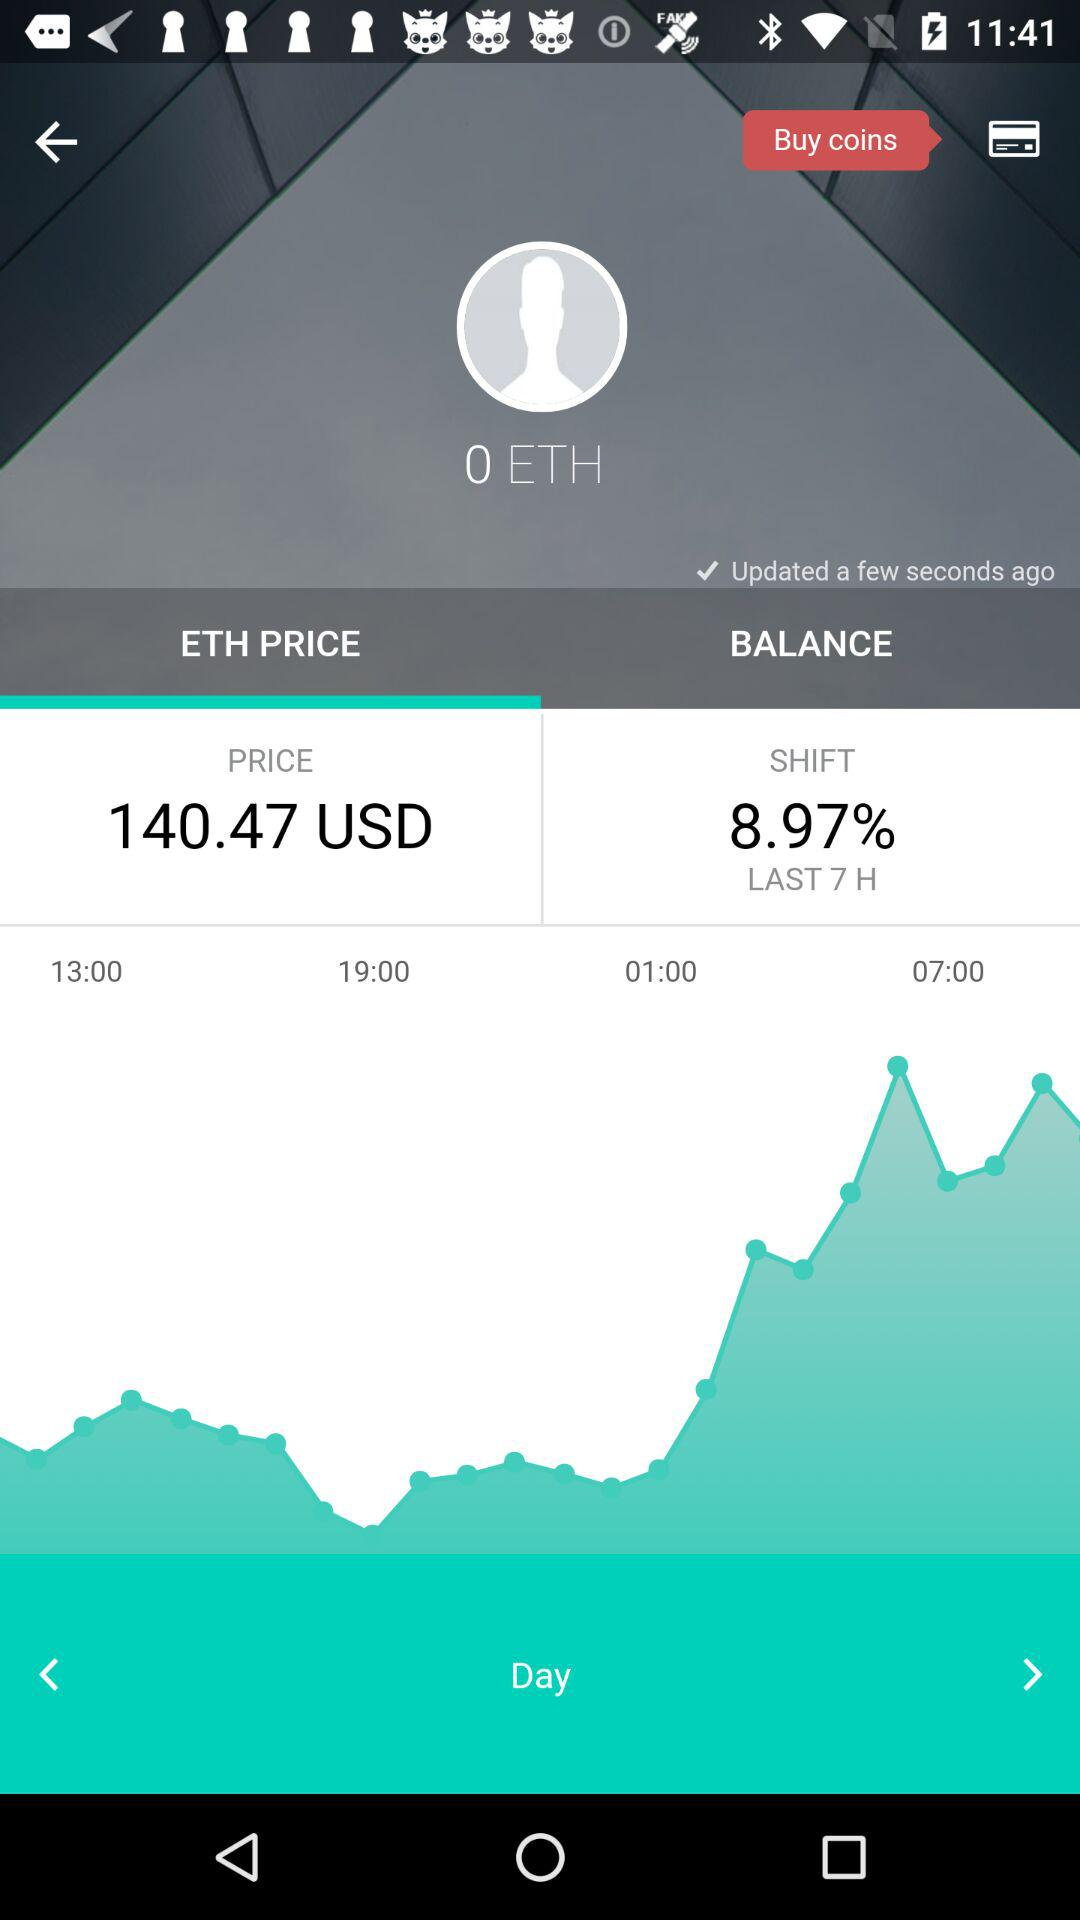What is the count of coins displayed?
When the provided information is insufficient, respond with <no answer>. <no answer> 